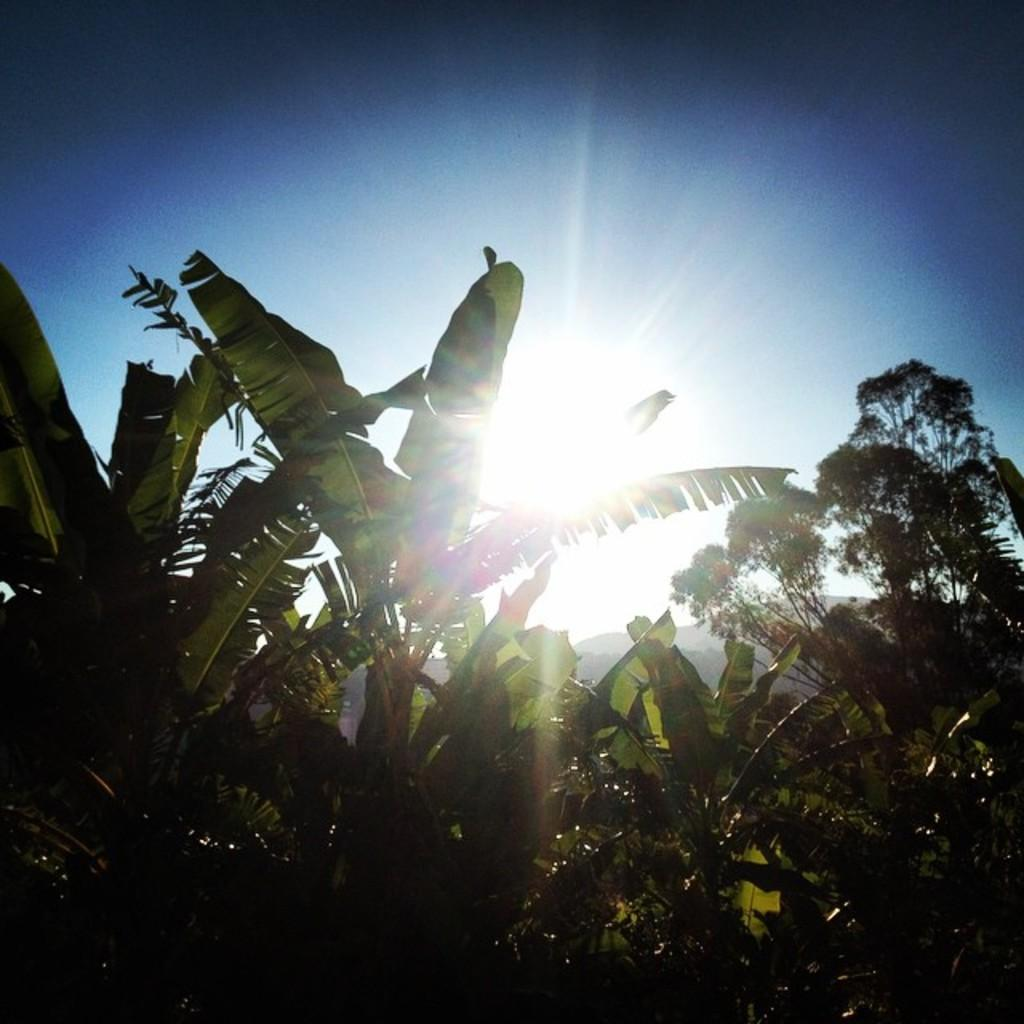What type of vegetation can be seen in the image? There are trees in the image. What part of the natural environment is visible in the image? The sky is visible in the image. What type of veil is draped over the trees in the image? There is no veil present in the image; it only features trees and the sky. What type of plastic material can be seen in the image? There is no plastic material present in the image. 